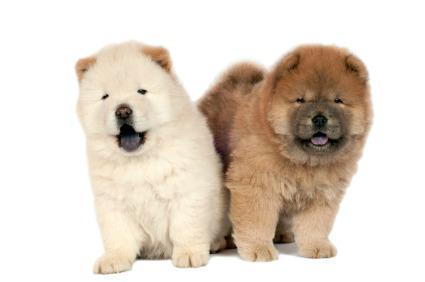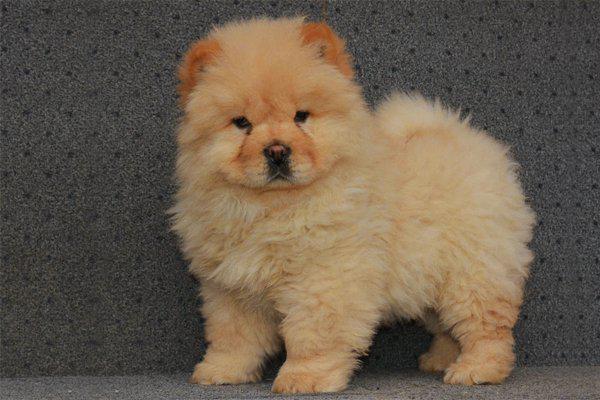The first image is the image on the left, the second image is the image on the right. For the images shown, is this caption "Three puppies sit side by side on a white cloth in one image, while a single pup appears in the other image, all with their mouths closed." true? Answer yes or no. No. The first image is the image on the left, the second image is the image on the right. Examine the images to the left and right. Is the description "In one of the images there are three puppies sitting in a row." accurate? Answer yes or no. No. 